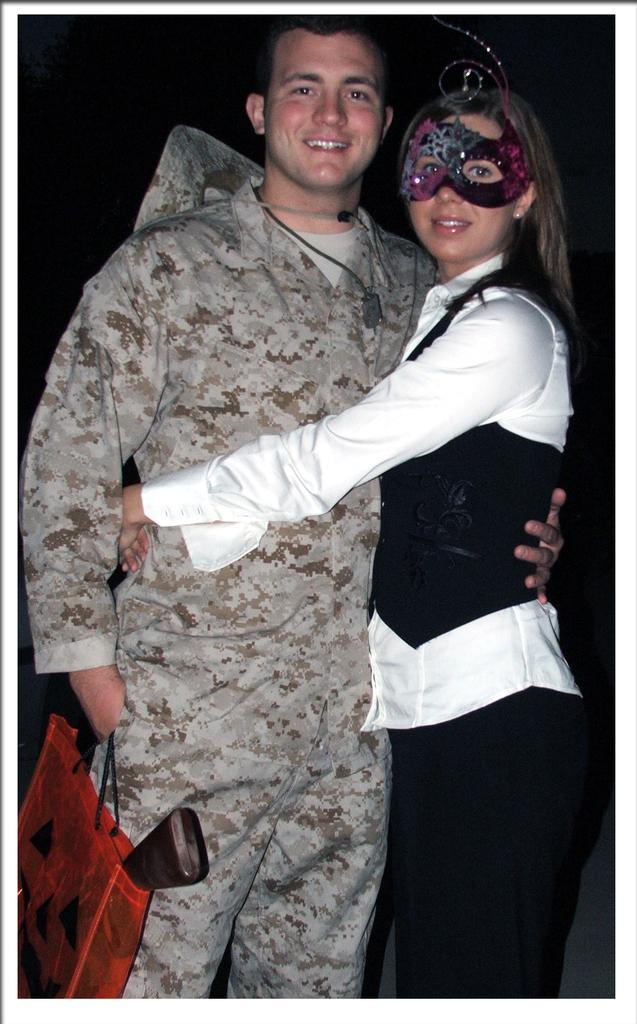Can you describe this image briefly? In this picture we can see a man and woman, he is holding a bag and she wore a mask, also we can see dark background. 